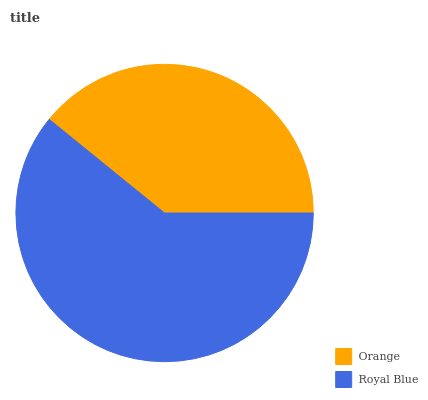Is Orange the minimum?
Answer yes or no. Yes. Is Royal Blue the maximum?
Answer yes or no. Yes. Is Royal Blue the minimum?
Answer yes or no. No. Is Royal Blue greater than Orange?
Answer yes or no. Yes. Is Orange less than Royal Blue?
Answer yes or no. Yes. Is Orange greater than Royal Blue?
Answer yes or no. No. Is Royal Blue less than Orange?
Answer yes or no. No. Is Royal Blue the high median?
Answer yes or no. Yes. Is Orange the low median?
Answer yes or no. Yes. Is Orange the high median?
Answer yes or no. No. Is Royal Blue the low median?
Answer yes or no. No. 